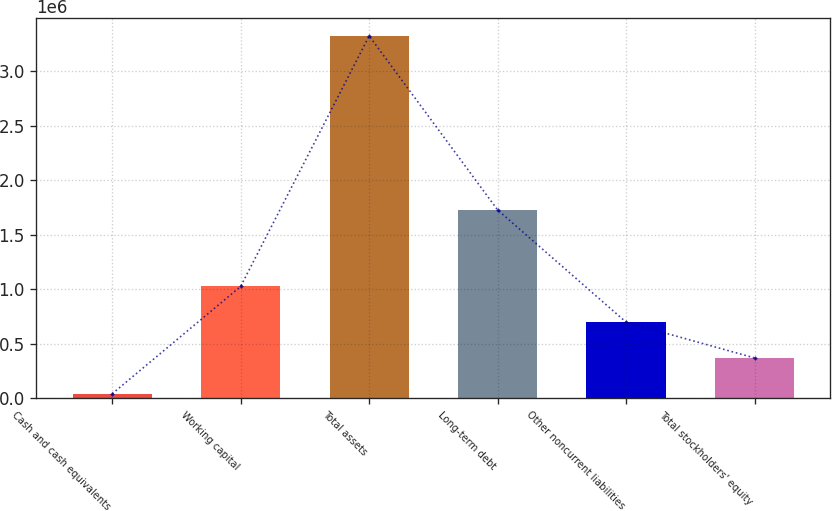Convert chart to OTSL. <chart><loc_0><loc_0><loc_500><loc_500><bar_chart><fcel>Cash and cash equivalents<fcel>Working capital<fcel>Total assets<fcel>Long-term debt<fcel>Other noncurrent liabilities<fcel>Total stockholders' equity<nl><fcel>38943<fcel>1.02523e+06<fcel>3.32656e+06<fcel>1.72755e+06<fcel>696467<fcel>367705<nl></chart> 